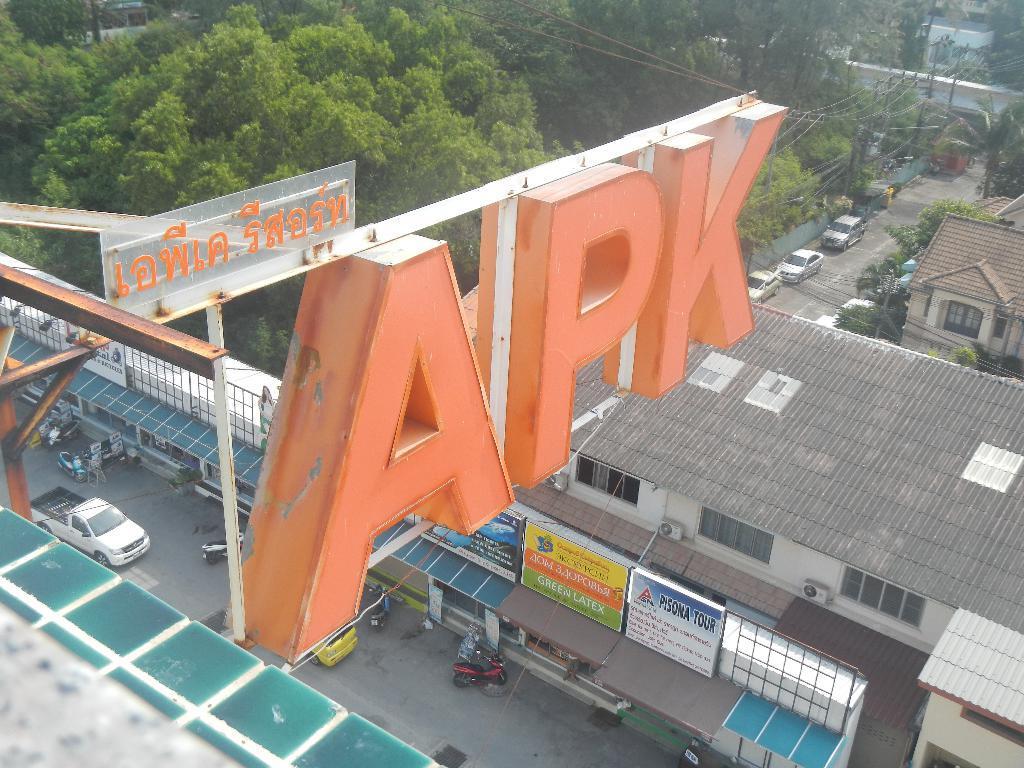Can you describe this image briefly? There is a hoarding which is attached to the building. Below this, there is a road, on which, there are vehicles. Beside this road, there is a building which is having glass windows and roof. Back to this building, there are vehicles parked aside on the road, near a building which is having glass window and roof. In the background, there are trees, plants, white wall and other objects. 